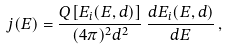<formula> <loc_0><loc_0><loc_500><loc_500>j ( E ) = \frac { Q [ E _ { i } ( E , d ) ] } { ( 4 \pi ) ^ { 2 } d ^ { 2 } } \, \frac { d E _ { i } ( E , d ) } { d E } \, ,</formula> 